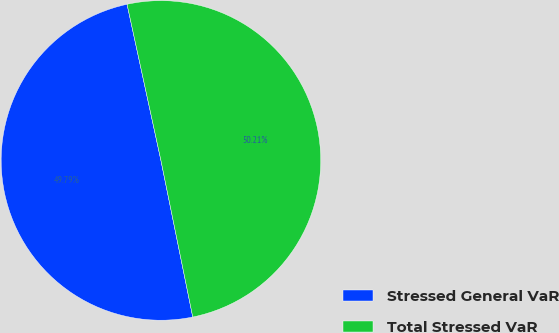Convert chart. <chart><loc_0><loc_0><loc_500><loc_500><pie_chart><fcel>Stressed General VaR<fcel>Total Stressed VaR<nl><fcel>49.79%<fcel>50.21%<nl></chart> 